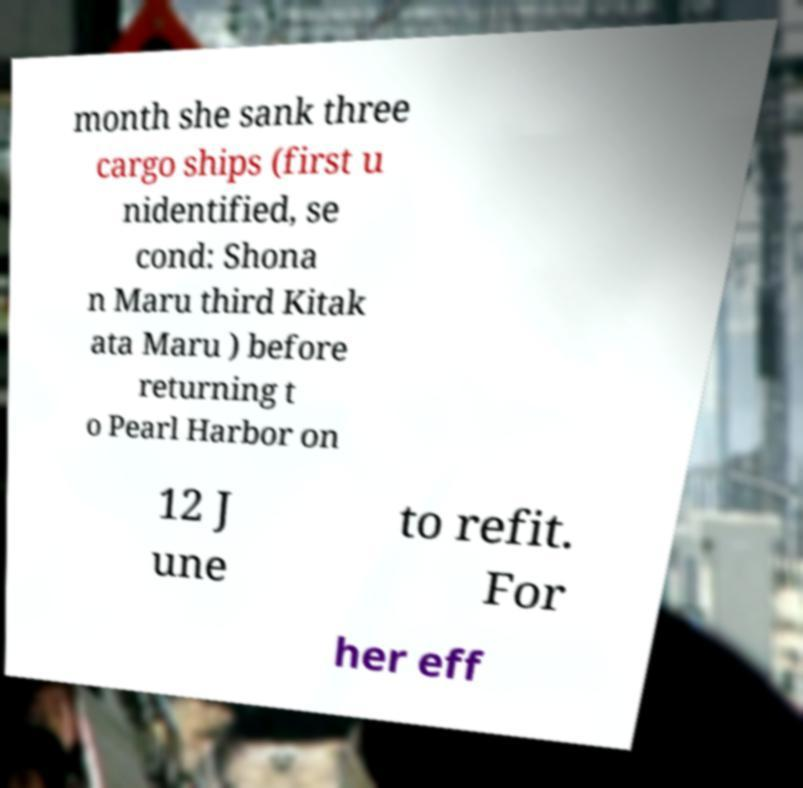For documentation purposes, I need the text within this image transcribed. Could you provide that? month she sank three cargo ships (first u nidentified, se cond: Shona n Maru third Kitak ata Maru ) before returning t o Pearl Harbor on 12 J une to refit. For her eff 